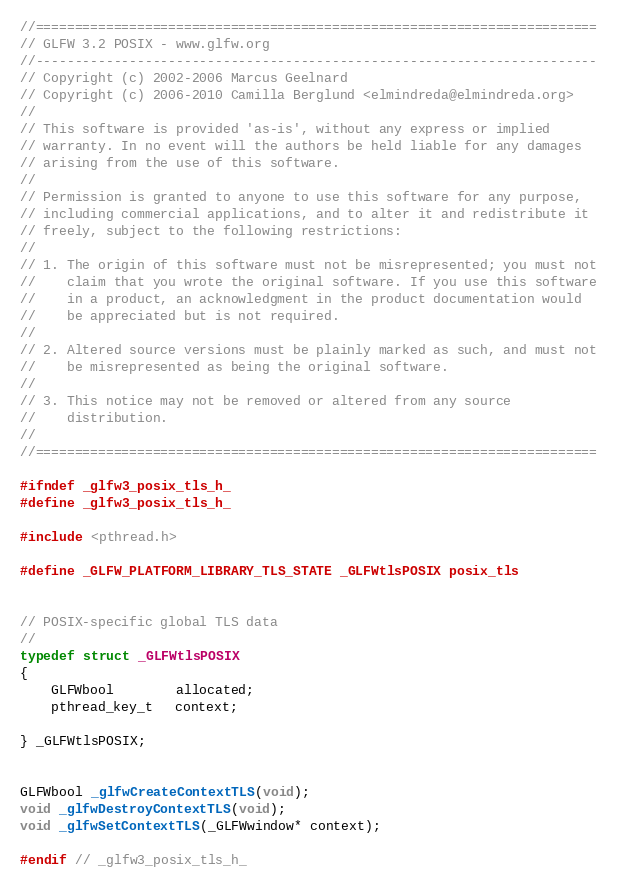Convert code to text. <code><loc_0><loc_0><loc_500><loc_500><_C_>//========================================================================
// GLFW 3.2 POSIX - www.glfw.org
//------------------------------------------------------------------------
// Copyright (c) 2002-2006 Marcus Geelnard
// Copyright (c) 2006-2010 Camilla Berglund <elmindreda@elmindreda.org>
//
// This software is provided 'as-is', without any express or implied
// warranty. In no event will the authors be held liable for any damages
// arising from the use of this software.
//
// Permission is granted to anyone to use this software for any purpose,
// including commercial applications, and to alter it and redistribute it
// freely, subject to the following restrictions:
//
// 1. The origin of this software must not be misrepresented; you must not
//    claim that you wrote the original software. If you use this software
//    in a product, an acknowledgment in the product documentation would
//    be appreciated but is not required.
//
// 2. Altered source versions must be plainly marked as such, and must not
//    be misrepresented as being the original software.
//
// 3. This notice may not be removed or altered from any source
//    distribution.
//
//========================================================================

#ifndef _glfw3_posix_tls_h_
#define _glfw3_posix_tls_h_

#include <pthread.h>

#define _GLFW_PLATFORM_LIBRARY_TLS_STATE _GLFWtlsPOSIX posix_tls


// POSIX-specific global TLS data
//
typedef struct _GLFWtlsPOSIX
{
    GLFWbool        allocated;
    pthread_key_t   context;

} _GLFWtlsPOSIX;


GLFWbool _glfwCreateContextTLS(void);
void _glfwDestroyContextTLS(void);
void _glfwSetContextTLS(_GLFWwindow* context);

#endif // _glfw3_posix_tls_h_
</code> 